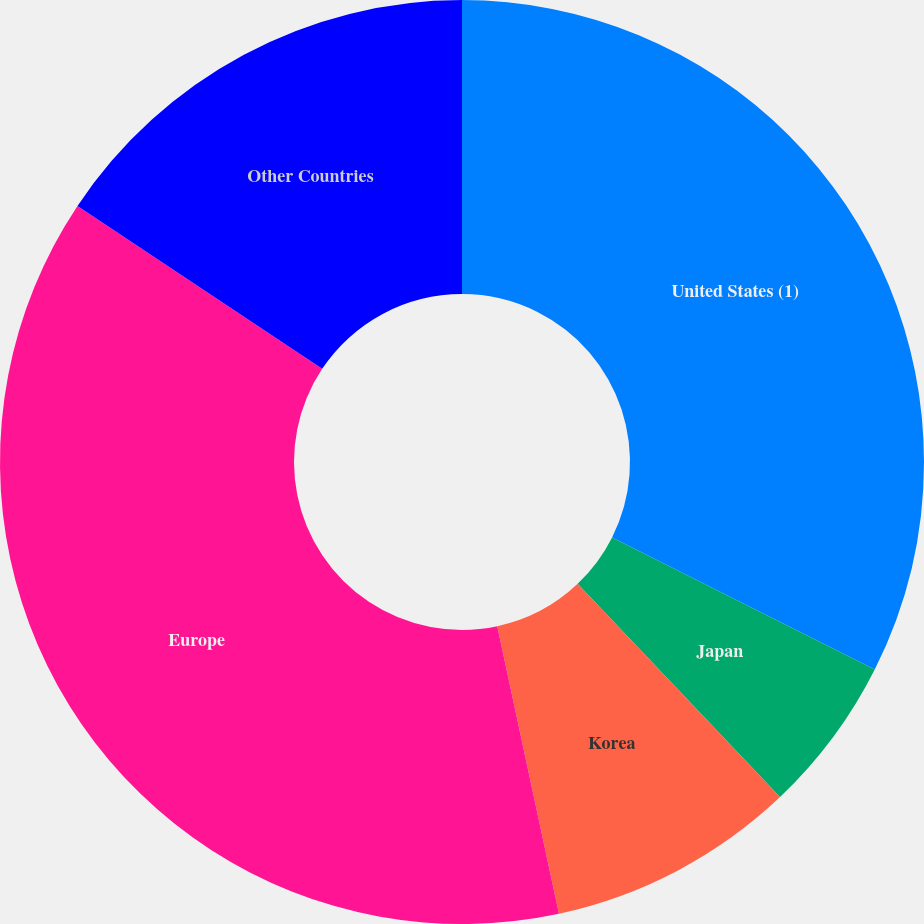<chart> <loc_0><loc_0><loc_500><loc_500><pie_chart><fcel>United States (1)<fcel>Japan<fcel>Korea<fcel>Europe<fcel>Other Countries<nl><fcel>32.42%<fcel>5.5%<fcel>8.72%<fcel>37.72%<fcel>15.65%<nl></chart> 